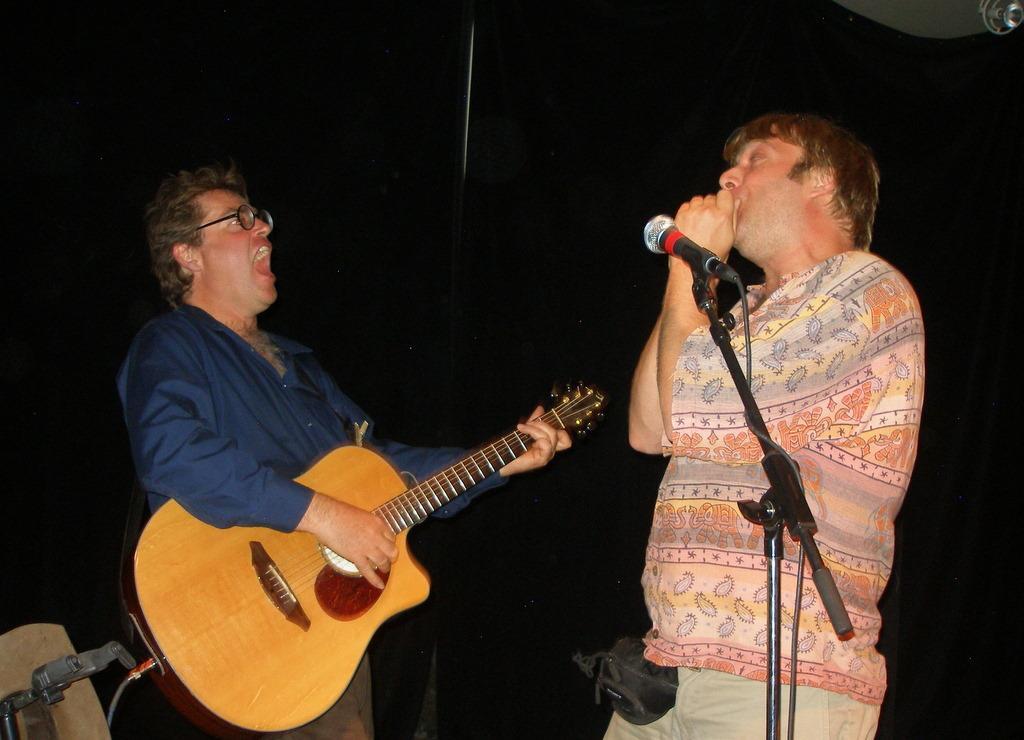Can you describe this image briefly? In this image there are two men. The man to the left corner is standing and playing guitar. It seems like he is shouting. The man to the right corner is standing and in front of him there is a microphone and its stand. In the background there is curtain. 